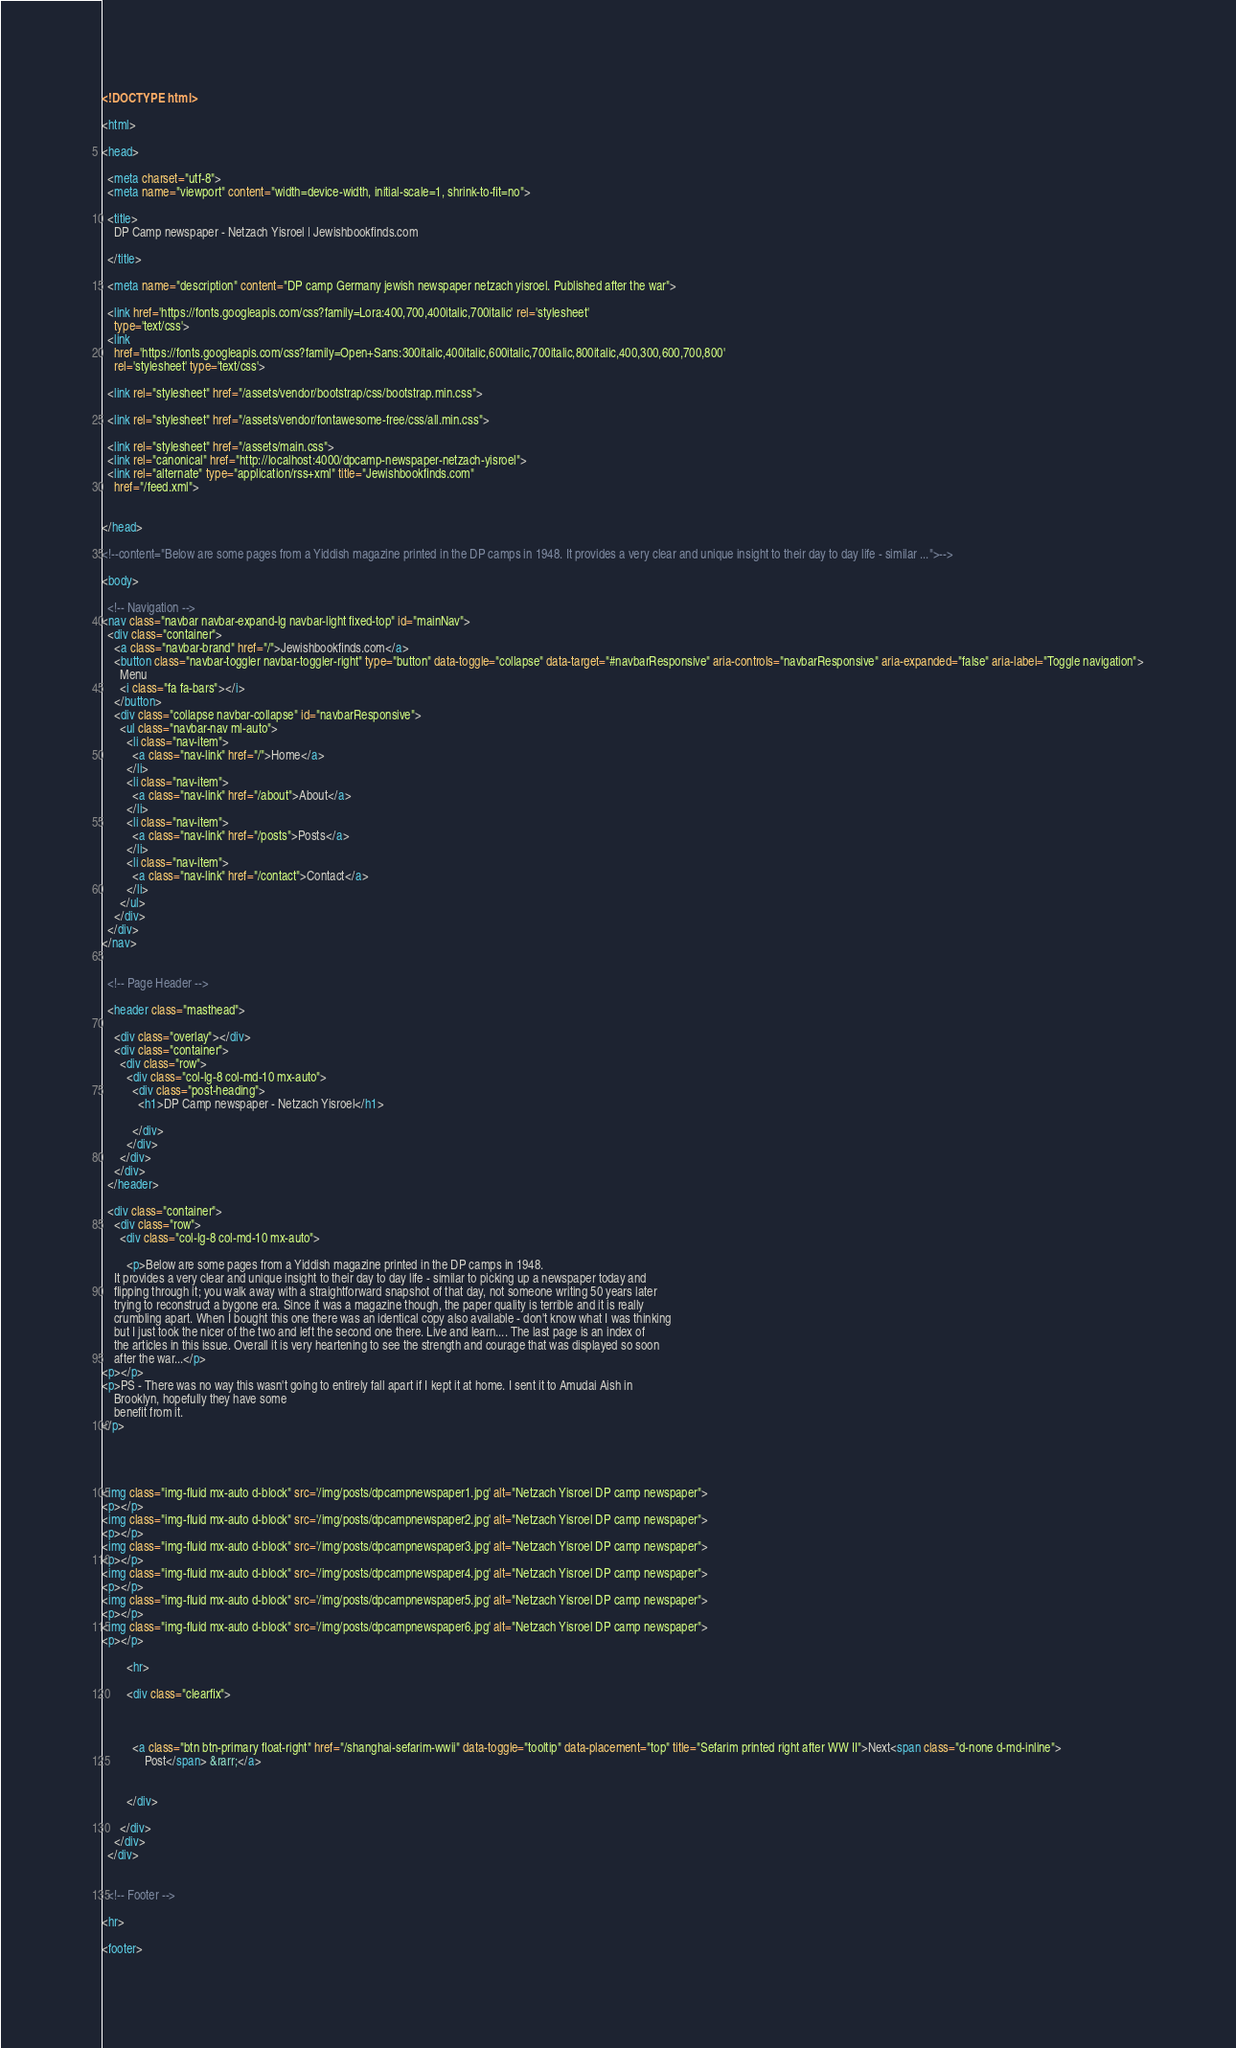<code> <loc_0><loc_0><loc_500><loc_500><_HTML_><!DOCTYPE html>

<html>

<head>

  <meta charset="utf-8">
  <meta name="viewport" content="width=device-width, initial-scale=1, shrink-to-fit=no">

  <title>
    DP Camp newspaper - Netzach Yisroel | Jewishbookfinds.com
    
  </title>

  <meta name="description" content="DP camp Germany jewish newspaper netzach yisroel. Published after the war">

  <link href='https://fonts.googleapis.com/css?family=Lora:400,700,400italic,700italic' rel='stylesheet'
    type='text/css'>
  <link
    href='https://fonts.googleapis.com/css?family=Open+Sans:300italic,400italic,600italic,700italic,800italic,400,300,600,700,800'
    rel='stylesheet' type='text/css'>

  <link rel="stylesheet" href="/assets/vendor/bootstrap/css/bootstrap.min.css">

  <link rel="stylesheet" href="/assets/vendor/fontawesome-free/css/all.min.css">

  <link rel="stylesheet" href="/assets/main.css">
  <link rel="canonical" href="http://localhost:4000/dpcamp-newspaper-netzach-yisroel">
  <link rel="alternate" type="application/rss+xml" title="Jewishbookfinds.com"
    href="/feed.xml">


</head>

<!--content="Below are some pages from a Yiddish magazine printed in the DP camps in 1948. It provides a very clear and unique insight to their day to day life - similar ...">-->

<body>

  <!-- Navigation -->
<nav class="navbar navbar-expand-lg navbar-light fixed-top" id="mainNav">
  <div class="container">
    <a class="navbar-brand" href="/">Jewishbookfinds.com</a>
    <button class="navbar-toggler navbar-toggler-right" type="button" data-toggle="collapse" data-target="#navbarResponsive" aria-controls="navbarResponsive" aria-expanded="false" aria-label="Toggle navigation">
      Menu
      <i class="fa fa-bars"></i>
    </button>
    <div class="collapse navbar-collapse" id="navbarResponsive">
      <ul class="navbar-nav ml-auto">
        <li class="nav-item">
          <a class="nav-link" href="/">Home</a>
        </li>
        <li class="nav-item">
          <a class="nav-link" href="/about">About</a>
        </li>
        <li class="nav-item">
          <a class="nav-link" href="/posts">Posts</a>
        </li>
        <li class="nav-item">
          <a class="nav-link" href="/contact">Contact</a>
        </li>
      </ul>
    </div>
  </div>
</nav>


  <!-- Page Header -->

  <header class="masthead">
    
    <div class="overlay"></div>
    <div class="container">
      <div class="row">
        <div class="col-lg-8 col-md-10 mx-auto">
          <div class="post-heading">
            <h1>DP Camp newspaper - Netzach Yisroel</h1>
            
          </div>
        </div>
      </div>
    </div>
  </header>

  <div class="container">
    <div class="row">
      <div class="col-lg-8 col-md-10 mx-auto">

        <p>Below are some pages from a Yiddish magazine printed in the DP camps in 1948.
    It provides a very clear and unique insight to their day to day life - similar to picking up a newspaper today and
    flipping through it; you walk away with a straightforward snapshot of that day, not someone writing 50 years later
    trying to reconstruct a bygone era. Since it was a magazine though, the paper quality is terrible and it is really
    crumbling apart. When I bought this one there was an identical copy also available - don't know what I was thinking
    but I just took the nicer of the two and left the second one there. Live and learn.... The last page is an index of
    the articles in this issue. Overall it is very heartening to see the strength and courage that was displayed so soon
    after the war...</p>
<p></p>
<p>PS - There was no way this wasn't going to entirely fall apart if I kept it at home. I sent it to Amudai Aish in
    Brooklyn, hopefully they have some
    benefit from it.
</p>




<img class="img-fluid mx-auto d-block" src='/img/posts/dpcampnewspaper1.jpg' alt="Netzach Yisroel DP camp newspaper">
<p></p>
<img class="img-fluid mx-auto d-block" src='/img/posts/dpcampnewspaper2.jpg' alt="Netzach Yisroel DP camp newspaper">
<p></p>
<img class="img-fluid mx-auto d-block" src='/img/posts/dpcampnewspaper3.jpg' alt="Netzach Yisroel DP camp newspaper">
<p></p>
<img class="img-fluid mx-auto d-block" src='/img/posts/dpcampnewspaper4.jpg' alt="Netzach Yisroel DP camp newspaper">
<p></p>
<img class="img-fluid mx-auto d-block" src='/img/posts/dpcampnewspaper5.jpg' alt="Netzach Yisroel DP camp newspaper">
<p></p>
<img class="img-fluid mx-auto d-block" src='/img/posts/dpcampnewspaper6.jpg' alt="Netzach Yisroel DP camp newspaper">
<p></p>

        <hr>

        <div class="clearfix">

          
          
          <a class="btn btn-primary float-right" href="/shanghai-sefarim-wwii" data-toggle="tooltip" data-placement="top" title="Sefarim printed right after WW II">Next<span class="d-none d-md-inline">
              Post</span> &rarr;</a>
          

        </div>

      </div>
    </div>
  </div>


  <!-- Footer -->

<hr>

<footer></code> 